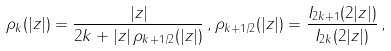Convert formula to latex. <formula><loc_0><loc_0><loc_500><loc_500>\rho _ { k } ( | z | ) = \frac { | z | } { 2 k + | z | \, \rho _ { k + 1 / 2 } ( | z | ) } \, , \rho _ { k + 1 / 2 } ( | z | ) = \frac { I _ { 2 k + 1 } ( 2 | z | ) } { I _ { 2 k } ( 2 | z | ) } \, ,</formula> 